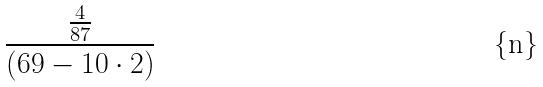Convert formula to latex. <formula><loc_0><loc_0><loc_500><loc_500>\frac { \frac { 4 } { 8 7 } } { ( 6 9 - 1 0 \cdot 2 ) }</formula> 